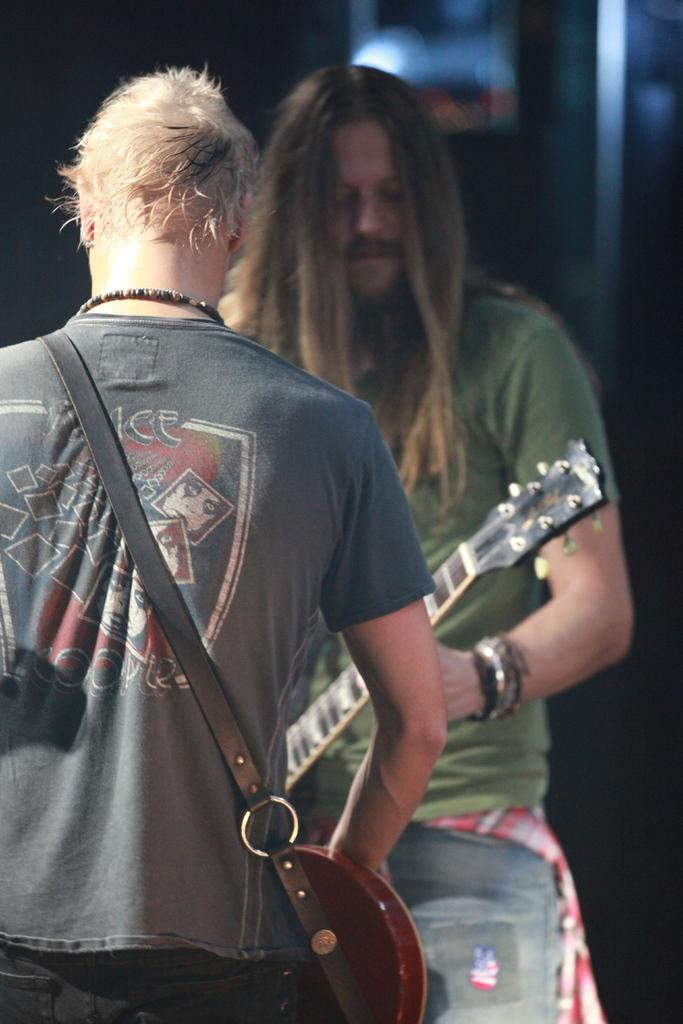How many people are in the image? There are two men in the image. What is one of the men doing in the image? One man is playing a guitar. What is the other man holding in the image? The other man is holding a musical instrument across his shoulders. What type of food is being served at the border in the image? There is no mention of food or a border in the image; it features two men, one playing a guitar and the other holding a musical instrument. 